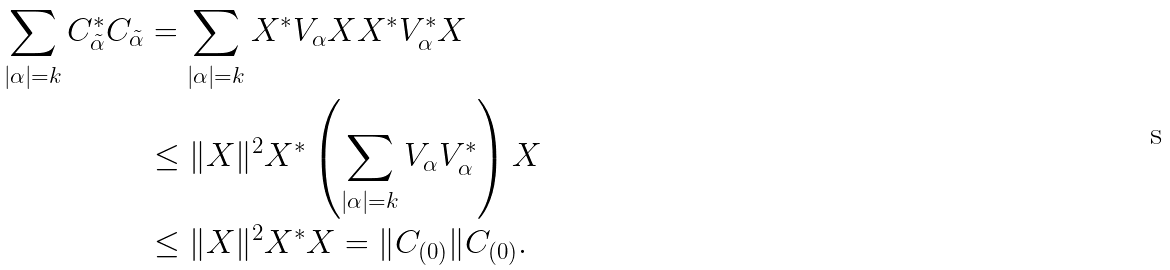Convert formula to latex. <formula><loc_0><loc_0><loc_500><loc_500>\sum _ { | \alpha | = k } C _ { \tilde { \alpha } } ^ { * } C _ { \tilde { \alpha } } & = \sum _ { | \alpha | = k } X ^ { * } V _ { \alpha } X X ^ { * } V _ { \alpha } ^ { * } X \\ & \leq \| X \| ^ { 2 } X ^ { * } \left ( \sum _ { | \alpha | = k } V _ { \alpha } V _ { \alpha } ^ { * } \right ) X \\ & \leq \| X \| ^ { 2 } X ^ { * } X = \| C _ { ( 0 ) } \| C _ { ( 0 ) } .</formula> 